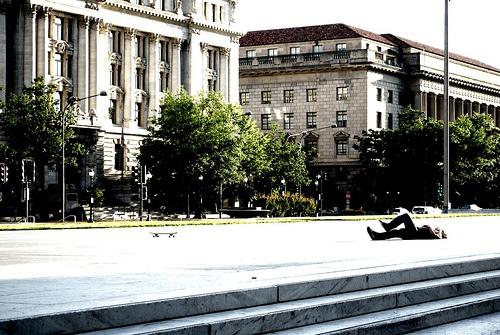Describe the objects in this image and their specific colors. I can see people in black, white, gray, and darkgray tones, traffic light in black, lightgray, gray, and darkgray tones, traffic light in black, gray, and ivory tones, traffic light in black, darkgray, gray, and white tones, and car in black, white, darkgray, and gray tones in this image. 